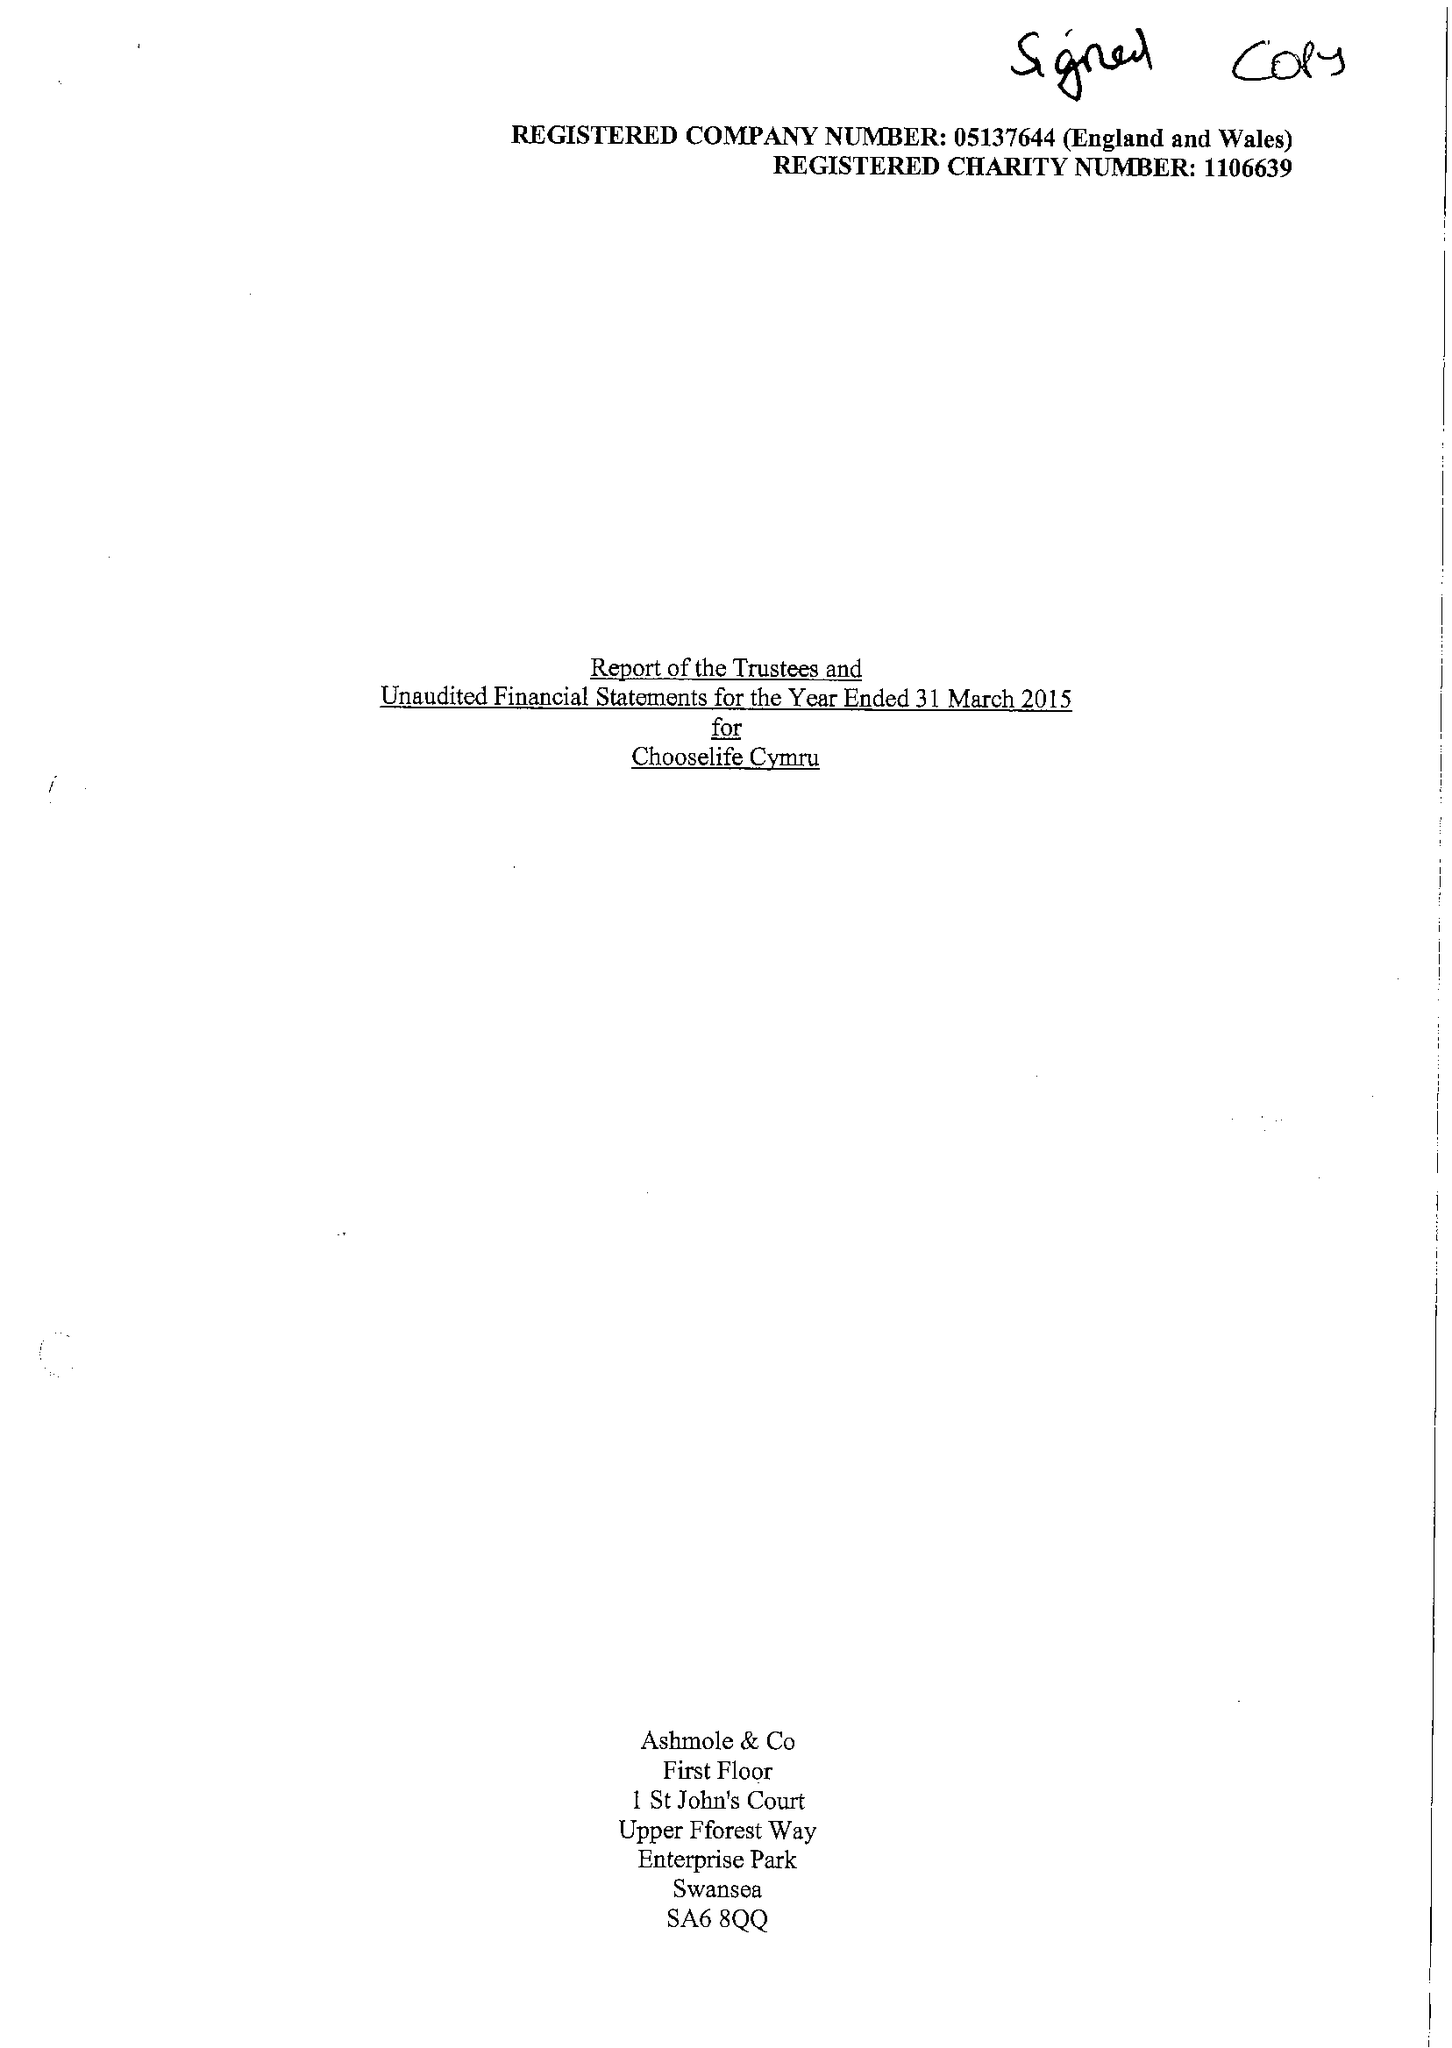What is the value for the address__postcode?
Answer the question using a single word or phrase. SA15 2NE 